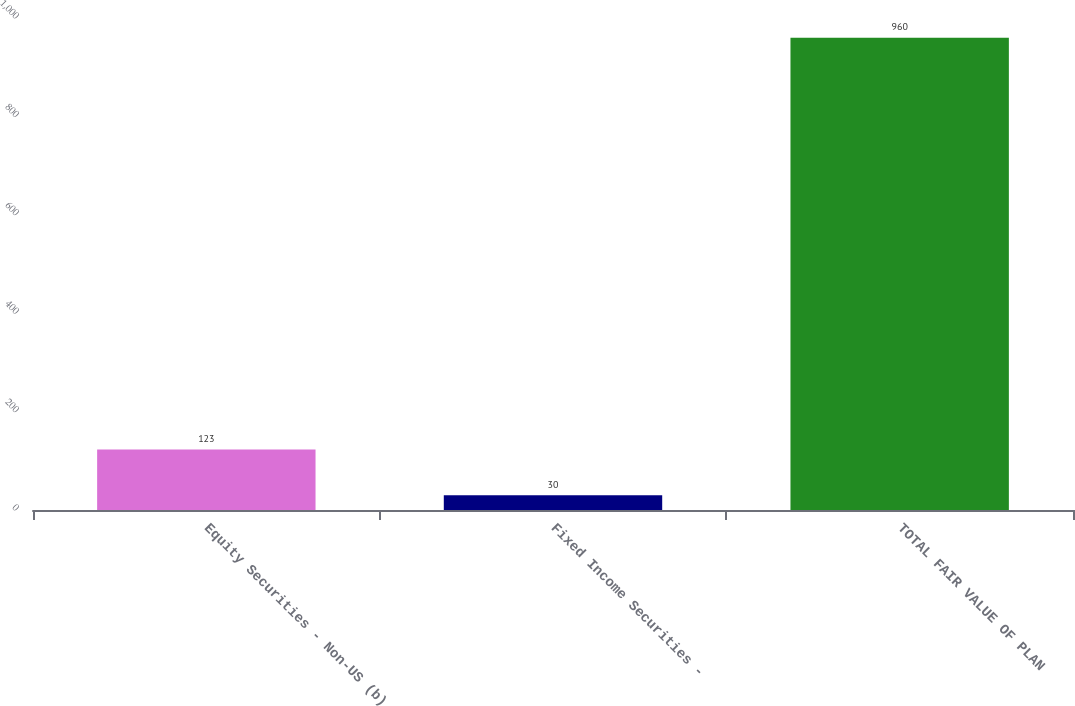<chart> <loc_0><loc_0><loc_500><loc_500><bar_chart><fcel>Equity Securities - Non-US (b)<fcel>Fixed Income Securities -<fcel>TOTAL FAIR VALUE OF PLAN<nl><fcel>123<fcel>30<fcel>960<nl></chart> 